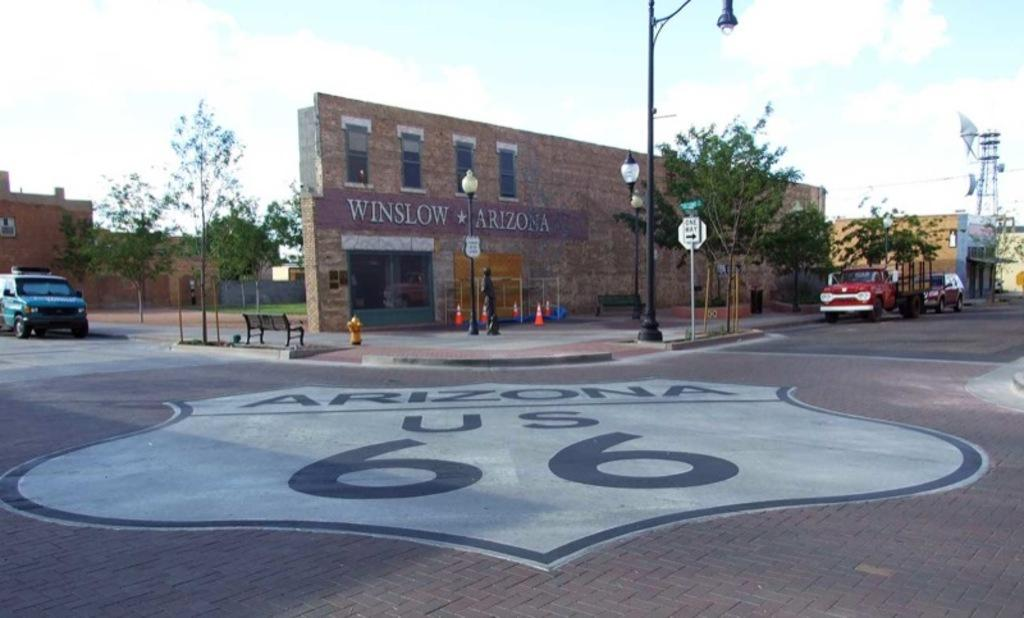What are the people in the image doing? The people in the image are walking. What can be seen on the left side of the road in the image? There are cars parked on the left side of the road. What type of structure is present in the image? There is a building in the image. What type of vegetation is present in the image? There is a tree in the image. What is the condition of the sky in the image? The sky is clear in the image. What type of treatment is being administered to the tree in the image? There is no treatment being administered to the tree in the image; it is a regular tree. What type of stitch is being used by the building in the image? There is no stitch being used by the building in the image; it is a regular building. 